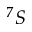<formula> <loc_0><loc_0><loc_500><loc_500>^ { 7 } S</formula> 